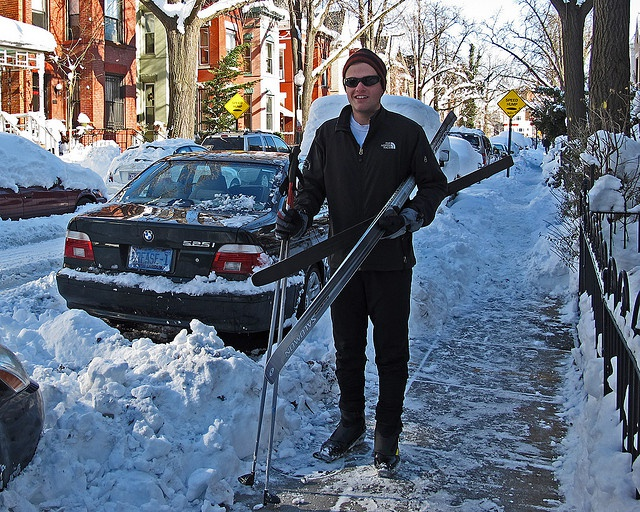Describe the objects in this image and their specific colors. I can see people in salmon, black, gray, and blue tones, car in salmon, black, blue, navy, and gray tones, car in salmon, black, darkgray, lightblue, and gray tones, car in salmon, black, and gray tones, and car in salmon, lightblue, gray, and darkgray tones in this image. 